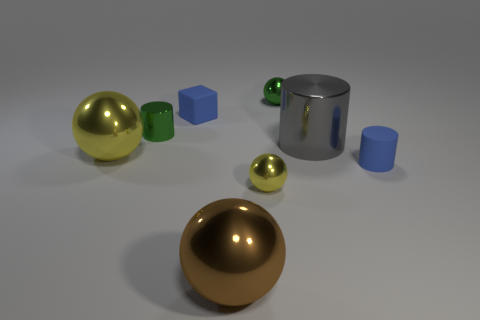Subtract all small cylinders. How many cylinders are left? 1 Add 2 cylinders. How many objects exist? 10 Subtract all brown spheres. How many spheres are left? 3 Subtract all yellow shiny spheres. Subtract all spheres. How many objects are left? 2 Add 6 yellow balls. How many yellow balls are left? 8 Add 3 small yellow shiny things. How many small yellow shiny things exist? 4 Subtract 1 blue cubes. How many objects are left? 7 Subtract all cylinders. How many objects are left? 5 Subtract 3 cylinders. How many cylinders are left? 0 Subtract all yellow cylinders. Subtract all yellow balls. How many cylinders are left? 3 